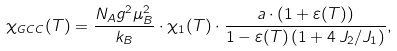<formula> <loc_0><loc_0><loc_500><loc_500>\chi _ { G C C } ( T ) = \frac { N _ { A } g ^ { 2 } \mu _ { B } ^ { 2 } } { k _ { B } } \cdot \chi _ { 1 } ( T ) \cdot \frac { a \cdot ( 1 + \varepsilon ( T ) ) } { 1 - \varepsilon ( T ) \left ( 1 + 4 \, J _ { 2 } / J _ { 1 } \right ) } ,</formula> 